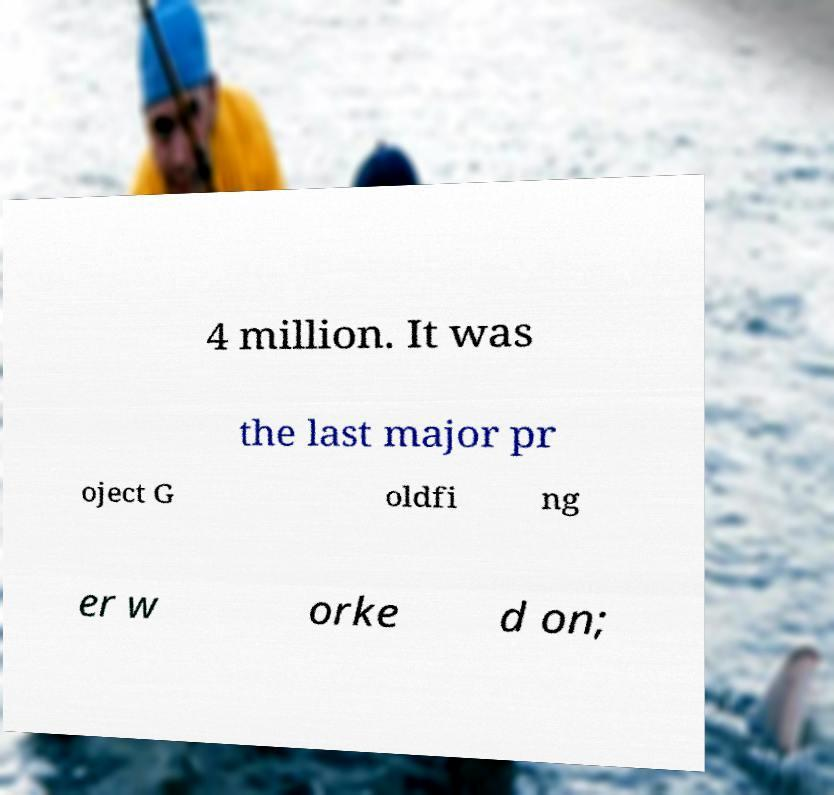Please identify and transcribe the text found in this image. 4 million. It was the last major pr oject G oldfi ng er w orke d on; 